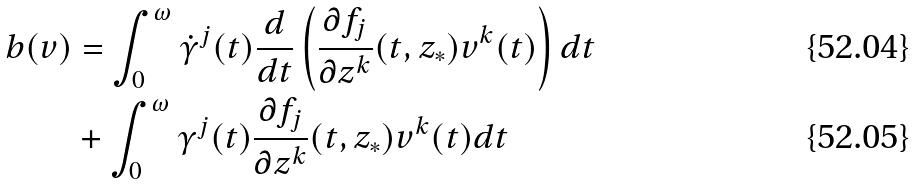<formula> <loc_0><loc_0><loc_500><loc_500>b ( v ) & = \int _ { 0 } ^ { \omega } \dot { \gamma } ^ { j } ( t ) \frac { d } { d t } \left ( \frac { \partial f _ { j } } { \partial z ^ { k } } ( t , z _ { * } ) v ^ { k } ( t ) \right ) d t \\ & + \int _ { 0 } ^ { \omega } \gamma ^ { j } ( t ) \frac { \partial f _ { j } } { \partial z ^ { k } } ( t , z _ { * } ) v ^ { k } ( t ) d t</formula> 